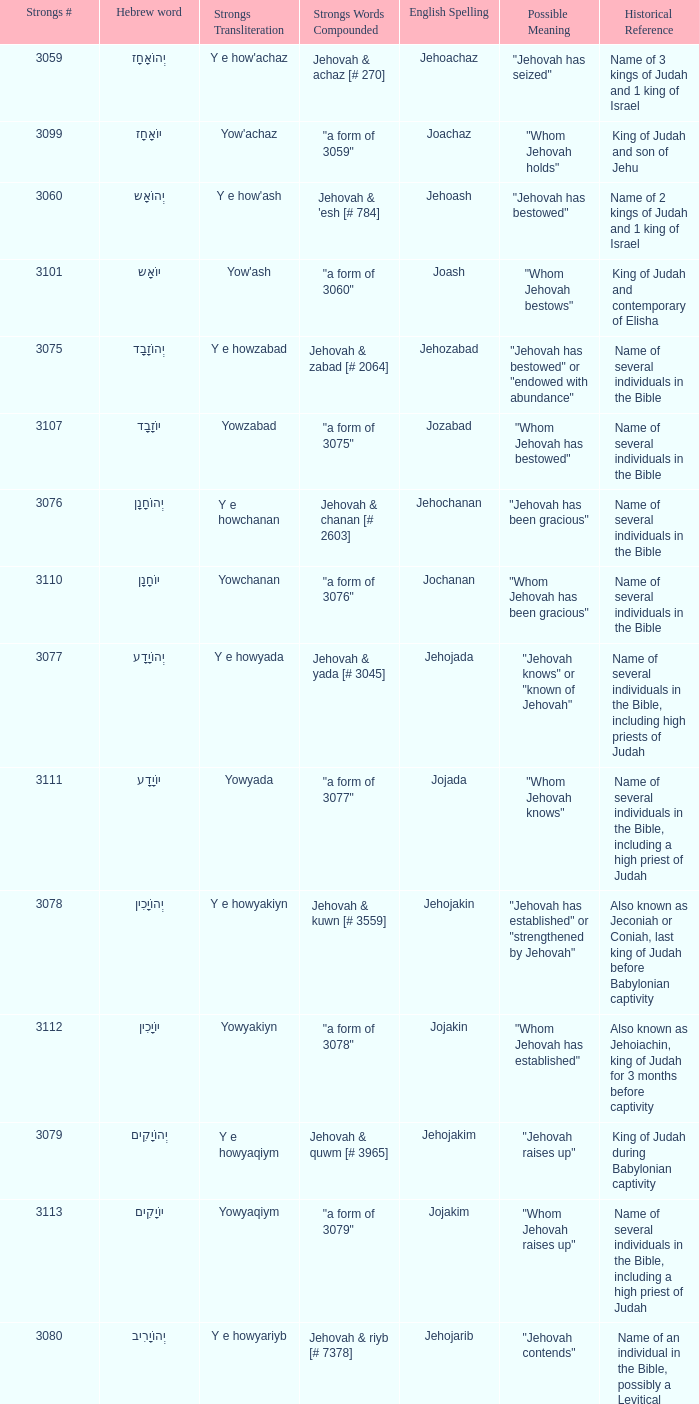What is the english spelling of the word that has the strongs trasliteration of y e howram? Jehoram. 